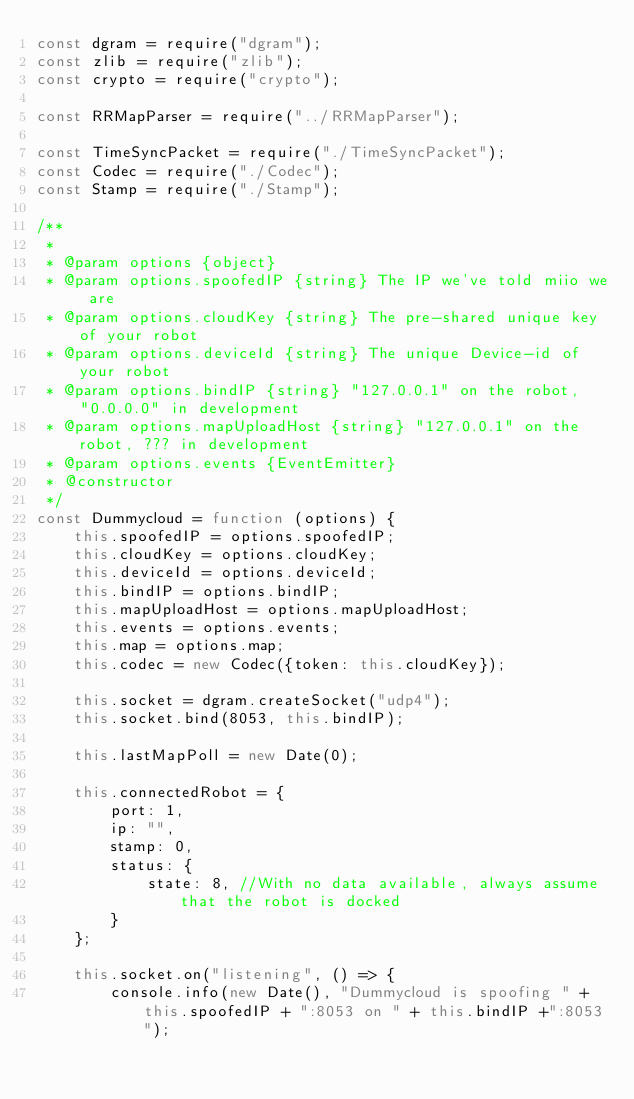<code> <loc_0><loc_0><loc_500><loc_500><_JavaScript_>const dgram = require("dgram");
const zlib = require("zlib");
const crypto = require("crypto");

const RRMapParser = require("../RRMapParser");

const TimeSyncPacket = require("./TimeSyncPacket");
const Codec = require("./Codec");
const Stamp = require("./Stamp");

/**
 *
 * @param options {object}
 * @param options.spoofedIP {string} The IP we've told miio we are
 * @param options.cloudKey {string} The pre-shared unique key of your robot
 * @param options.deviceId {string} The unique Device-id of your robot
 * @param options.bindIP {string} "127.0.0.1" on the robot, "0.0.0.0" in development
 * @param options.mapUploadHost {string} "127.0.0.1" on the robot, ??? in development
 * @param options.events {EventEmitter}
 * @constructor
 */
const Dummycloud = function (options) {
	this.spoofedIP = options.spoofedIP;
	this.cloudKey = options.cloudKey;
	this.deviceId = options.deviceId;
	this.bindIP = options.bindIP;
	this.mapUploadHost = options.mapUploadHost;
	this.events = options.events;
	this.map = options.map;
	this.codec = new Codec({token: this.cloudKey});

	this.socket = dgram.createSocket("udp4");
	this.socket.bind(8053, this.bindIP);

	this.lastMapPoll = new Date(0);

	this.connectedRobot = {
		port: 1,
		ip: "",
		stamp: 0,
		status: {
			state: 8, //With no data available, always assume that the robot is docked
		}
	};

	this.socket.on("listening", () => {
		console.info(new Date(), "Dummycloud is spoofing " + this.spoofedIP + ":8053 on " + this.bindIP +":8053");</code> 